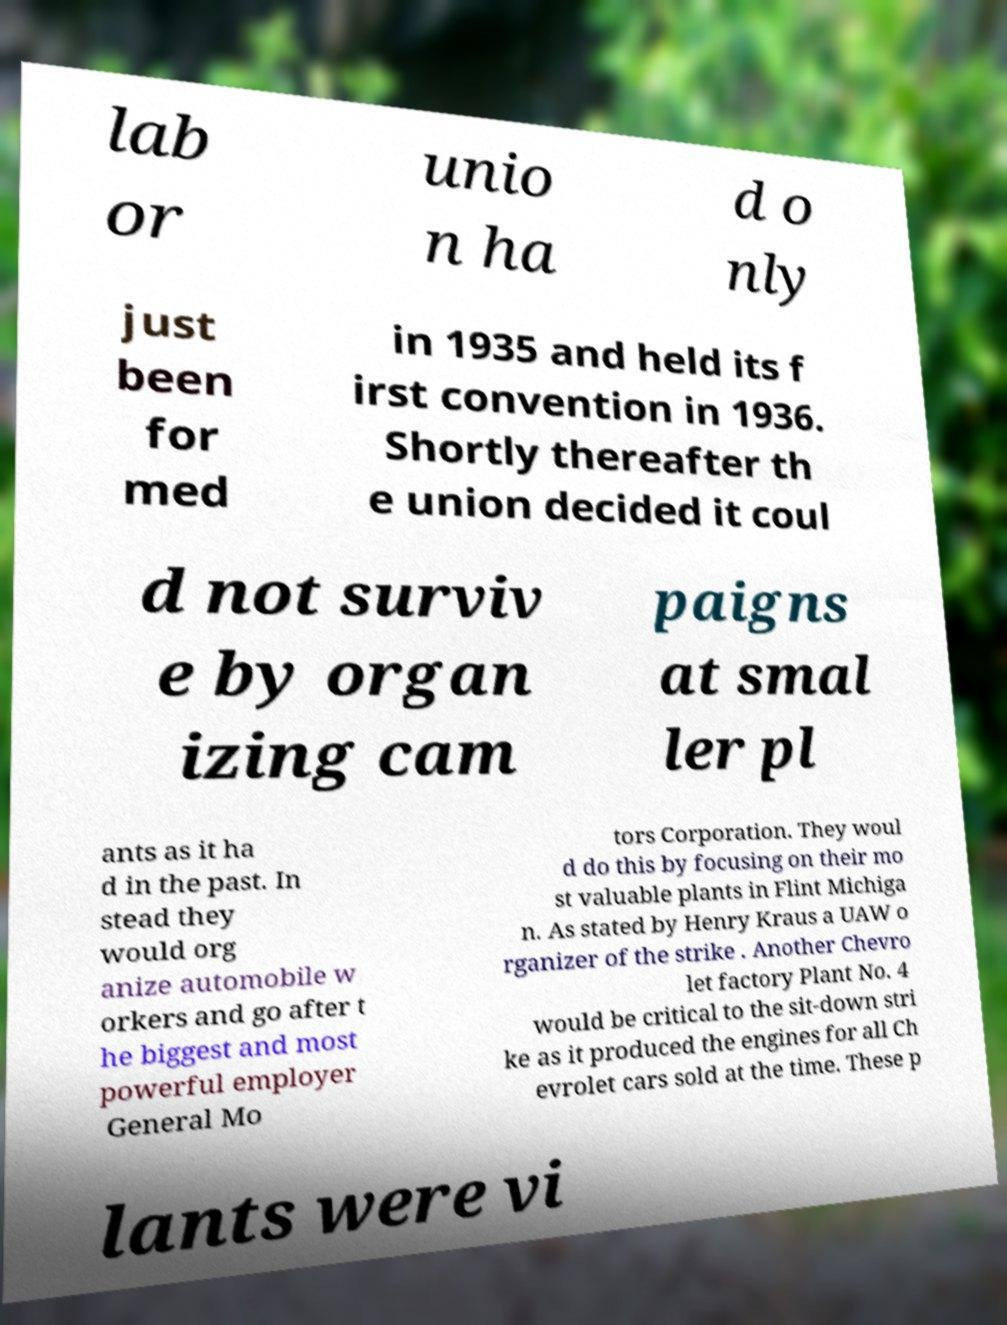For documentation purposes, I need the text within this image transcribed. Could you provide that? lab or unio n ha d o nly just been for med in 1935 and held its f irst convention in 1936. Shortly thereafter th e union decided it coul d not surviv e by organ izing cam paigns at smal ler pl ants as it ha d in the past. In stead they would org anize automobile w orkers and go after t he biggest and most powerful employer General Mo tors Corporation. They woul d do this by focusing on their mo st valuable plants in Flint Michiga n. As stated by Henry Kraus a UAW o rganizer of the strike . Another Chevro let factory Plant No. 4 would be critical to the sit-down stri ke as it produced the engines for all Ch evrolet cars sold at the time. These p lants were vi 